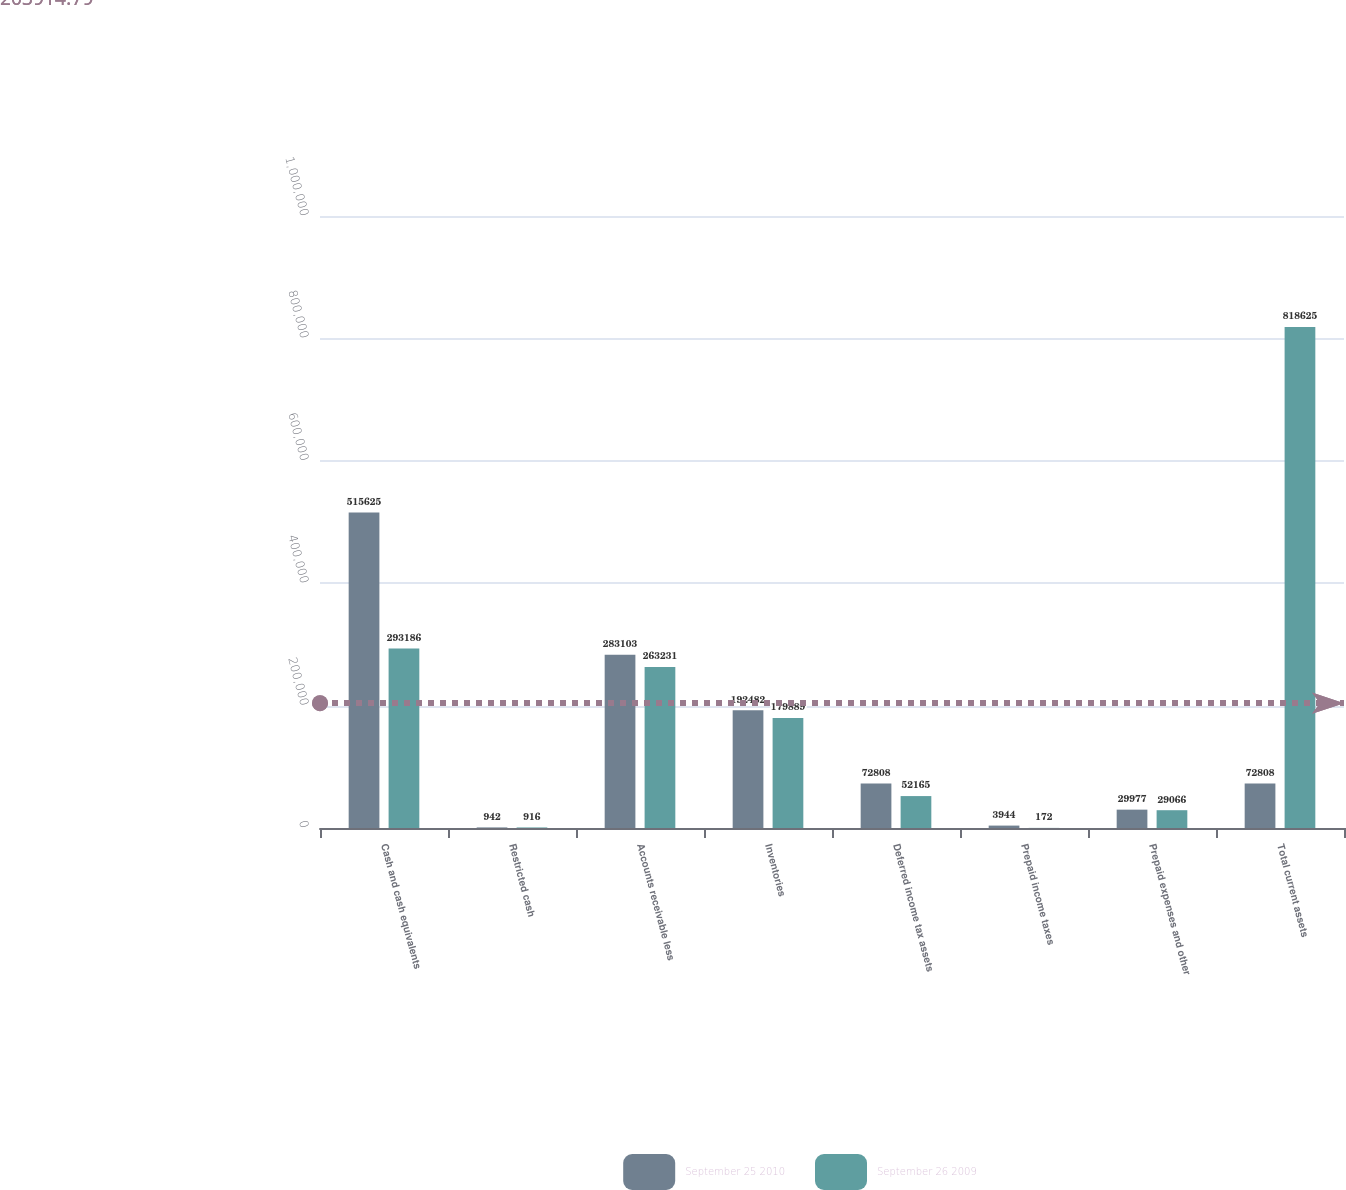Convert chart. <chart><loc_0><loc_0><loc_500><loc_500><stacked_bar_chart><ecel><fcel>Cash and cash equivalents<fcel>Restricted cash<fcel>Accounts receivable less<fcel>Inventories<fcel>Deferred income tax assets<fcel>Prepaid income taxes<fcel>Prepaid expenses and other<fcel>Total current assets<nl><fcel>September 25 2010<fcel>515625<fcel>942<fcel>283103<fcel>192482<fcel>72808<fcel>3944<fcel>29977<fcel>72808<nl><fcel>September 26 2009<fcel>293186<fcel>916<fcel>263231<fcel>179889<fcel>52165<fcel>172<fcel>29066<fcel>818625<nl></chart> 